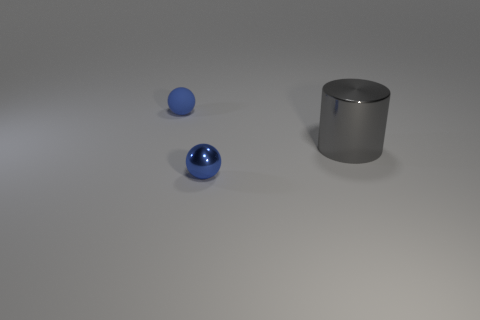Add 1 tiny blue balls. How many objects exist? 4 Subtract all cylinders. How many objects are left? 2 Subtract 0 green balls. How many objects are left? 3 Subtract all large gray cylinders. Subtract all large metal objects. How many objects are left? 1 Add 3 metallic cylinders. How many metallic cylinders are left? 4 Add 1 blue matte spheres. How many blue matte spheres exist? 2 